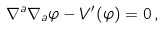<formula> <loc_0><loc_0><loc_500><loc_500>\nabla ^ { a } \nabla _ { a } \varphi - V ^ { \prime } ( \varphi ) = 0 \, ,</formula> 